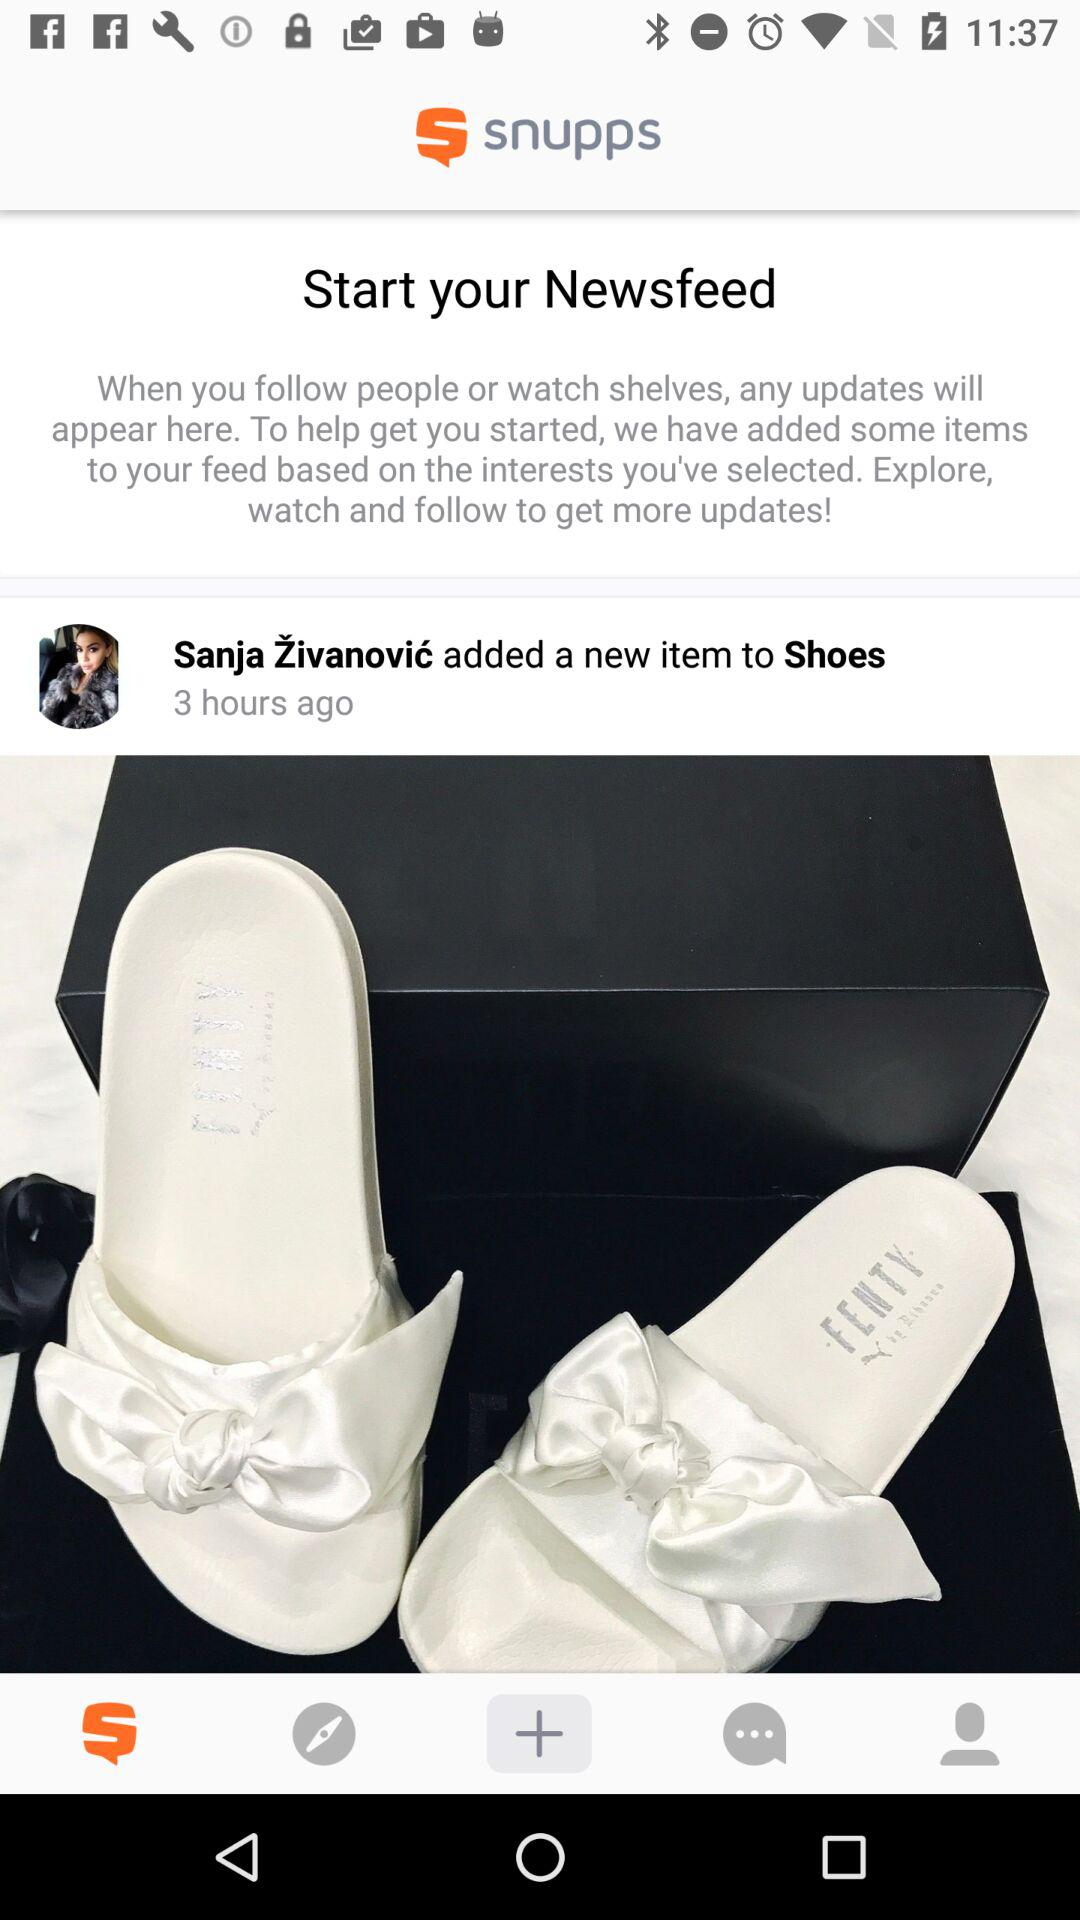What was the new item added to shoes was posted?
When the provided information is insufficient, respond with <no answer>. <no answer> 